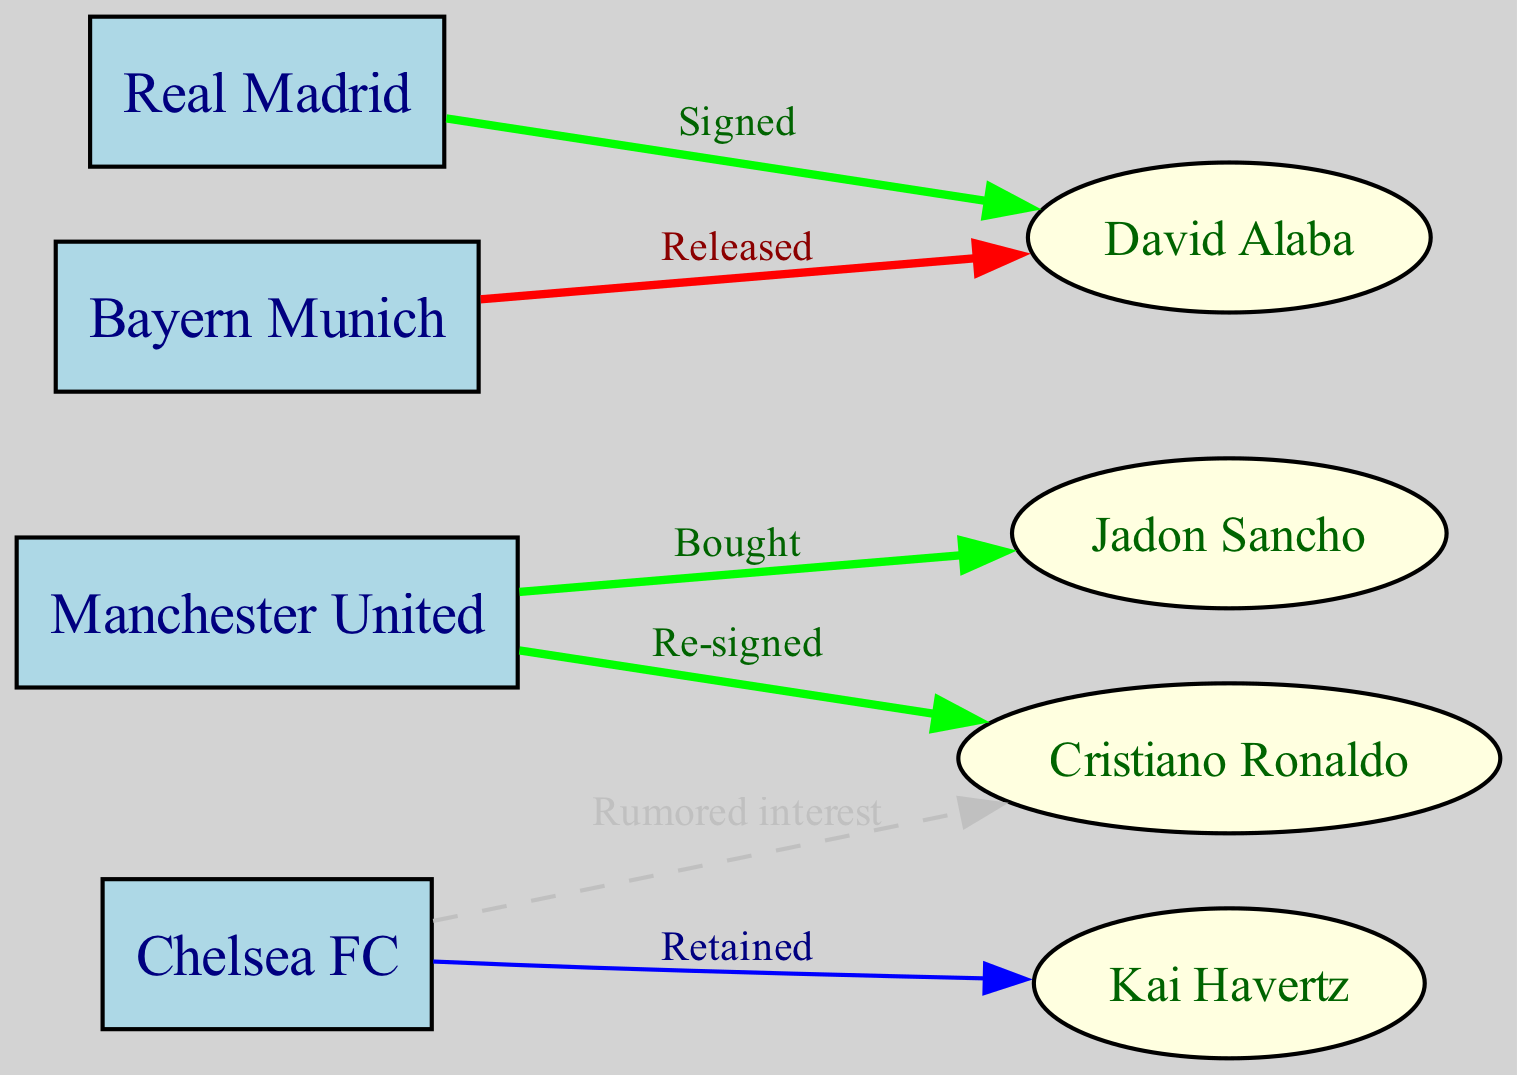What is the total number of players in the diagram? The diagram contains nodes representing clubs and players. By counting the number of distinct players present in the 'nodes' list, we identify four players: Cristiano Ronaldo, Kai Havertz, David Alaba, and Jadon Sancho.
Answer: 4 How many clubs are represented in the diagram? The clubs that are specified in the 'nodes' list include Manchester United, Chelsea FC, Real Madrid, and Bayern Munich. Counting these gives a total of four clubs.
Answer: 4 Which player is connected to Manchester United with a "Bought" label? In the 'edges' data, we see that there is a connection from Manchester United to Jadon Sancho labeled as "Bought." Therefore, Jadon Sancho is the player connected by that edge.
Answer: Jadon Sancho What type of transfer is indicated between Bayern Munich and David Alaba? The edge from Bayern Munich to David Alaba is labeled as "Released." This indicates that Alaba has been released from Bayern Munich.
Answer: Released Which club has a "Rumored interest" in Cristiano Ronaldo? The diagram shows a dashed edge from Chelsea FC to Cristiano Ronaldo, labeled as "Rumored interest." This indicates that Chelsea FC is interested in Ronaldo.
Answer: Chelsea FC How many edges represent a transfer where the player was "Signed"? Looking at the 'edges,' we find that there is one edge from Bayern Munich to David Alaba labeled "Signed," indicating one signing transfer.
Answer: 1 Which player switched from Bayern Munich to Real Madrid? The edge from Bayern Munich to Real Madrid indicates that David Alaba signed with Real Madrid after being released by Bayern Munich. Therefore, Alaba is the player who switched clubs.
Answer: David Alaba Which club is connected to the most players in the diagram? By examining the 'edges,' Manchester United connects to Cristiano Ronaldo (re-signed) and Jadon Sancho (bought), while Chelsea connects to Kai Havertz (retained) and Cristiano Ronaldo (rumored). Both clubs connect to two players, but considering the question of unique connections, it’s Manchester United with two unique connections.
Answer: Manchester United Which edge indicates that a player remained with their club? The edge from Chelsea FC to Kai Havertz is labeled "Retained," indicating that Havertz remained with Chelsea during the period depicted in the diagram.
Answer: Retained 